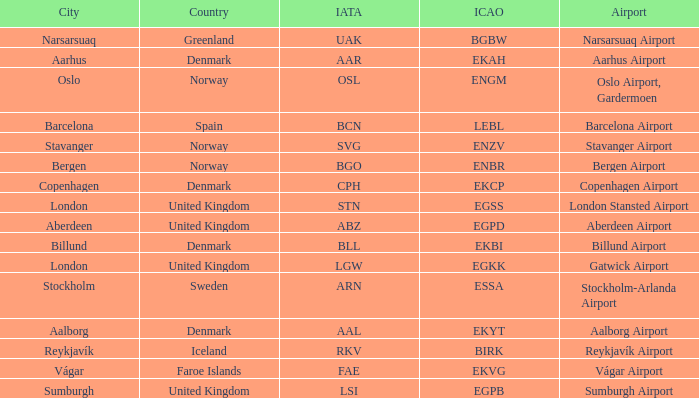What airport has an ICAP of BGBW? Narsarsuaq Airport. 